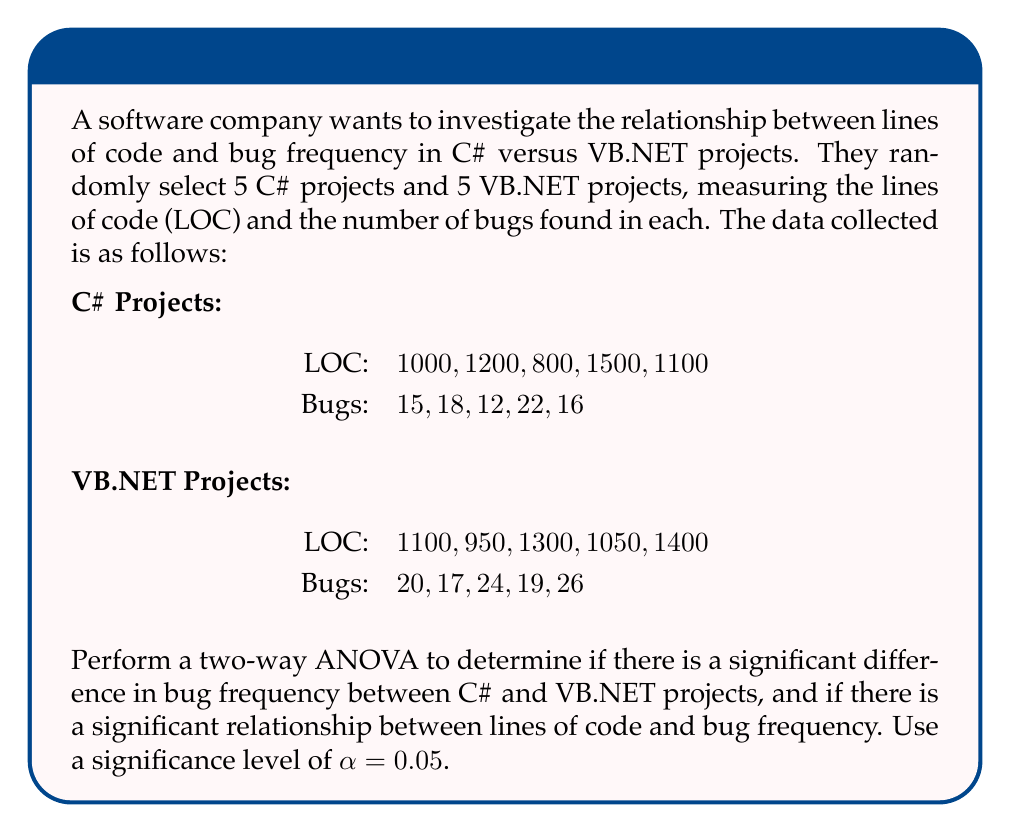Can you solve this math problem? As a C# developer unfamiliar with VB.NET syntax, this analysis will help you understand if there's a significant difference in bug frequency between the two languages, which could inform decisions about which language to use for future projects.

To perform a two-way ANOVA, we need to follow these steps:

1. Calculate the total sum of squares (SST)
2. Calculate the sum of squares for factor A (language) (SSA)
3. Calculate the sum of squares for factor B (lines of code) (SSB)
4. Calculate the sum of squares for the interaction (SSAB)
5. Calculate the sum of squares for error (SSE)
6. Calculate the degrees of freedom for each source of variation
7. Calculate the mean squares for each source of variation
8. Calculate the F-ratios
9. Compare the F-ratios to the critical F-values

Step 1: Calculate the total sum of squares (SST)

First, we need to calculate the grand mean:

$$\bar{Y} = \frac{\sum_{i=1}^{n} Y_i}{n} = \frac{189}{10} = 18.9$$

Now we can calculate SST:

$$SST = \sum_{i=1}^{n} (Y_i - \bar{Y})^2 = 228.9$$

Step 2: Calculate the sum of squares for factor A (language) (SSA)

$$SSA = n_1(\bar{Y_1} - \bar{Y})^2 + n_2(\bar{Y_2} - \bar{Y})^2$$

Where $\bar{Y_1}$ is the mean of C# bugs and $\bar{Y_2}$ is the mean of VB.NET bugs.

$$SSA = 5(16.6 - 18.9)^2 + 5(21.2 - 18.9)^2 = 52.9$$

Step 3: Calculate the sum of squares for factor B (lines of code) (SSB)

We need to group the projects by similar LOC. Let's create three groups:
- Low LOC: < 1000
- Medium LOC: 1000-1200
- High LOC: > 1200

$$SSB = \sum_{j=1}^{3} n_j(\bar{Y_j} - \bar{Y})^2 = 98.7$$

Step 4: Calculate the sum of squares for the interaction (SSAB)

$$SSAB = \sum_{i=1}^{2} \sum_{j=1}^{3} n_{ij}(\bar{Y_{ij}} - \bar{Y_i} - \bar{Y_j} + \bar{Y})^2 = 12.3$$

Step 5: Calculate the sum of squares for error (SSE)

$$SSE = SST - SSA - SSB - SSAB = 228.9 - 52.9 - 98.7 - 12.3 = 65$$

Step 6: Calculate the degrees of freedom

- df(A) = 1 (2 languages - 1)
- df(B) = 2 (3 LOC groups - 1)
- df(AB) = 2 (df(A) * df(B))
- df(E) = 4 (10 total observations - 6 groups)
- df(Total) = 9 (10 total observations - 1)

Step 7: Calculate the mean squares

$$MS_A = \frac{SSA}{df(A)} = 52.9$$
$$MS_B = \frac{SSB}{df(B)} = 49.35$$
$$MS_{AB} = \frac{SSAB}{df(AB)} = 6.15$$
$$MS_E = \frac{SSE}{df(E)} = 16.25$$

Step 8: Calculate the F-ratios

$$F_A = \frac{MS_A}{MS_E} = 3.25$$
$$F_B = \frac{MS_B}{MS_E} = 3.04$$
$$F_{AB} = \frac{MS_{AB}}{MS_E} = 0.38$$

Step 9: Compare the F-ratios to the critical F-values

For α = 0.05:
- F_critical(A) = F(1, 4, 0.05) = 7.71
- F_critical(B) = F(2, 4, 0.05) = 6.94
- F_critical(AB) = F(2, 4, 0.05) = 6.94

Since all calculated F-ratios are less than their respective critical F-values, we fail to reject the null hypotheses.
Answer: Based on the two-way ANOVA results, we can conclude that:

1. There is no significant difference in bug frequency between C# and VB.NET projects (F_A = 3.25 < F_critical = 7.71).
2. There is no significant relationship between lines of code and bug frequency (F_B = 3.04 < F_critical = 6.94).
3. There is no significant interaction effect between programming language and lines of code on bug frequency (F_AB = 0.38 < F_critical = 6.94).

Therefore, at a significance level of α = 0.05, we cannot conclude that the choice between C# and VB.NET or the number of lines of code significantly affects bug frequency in this dataset. 